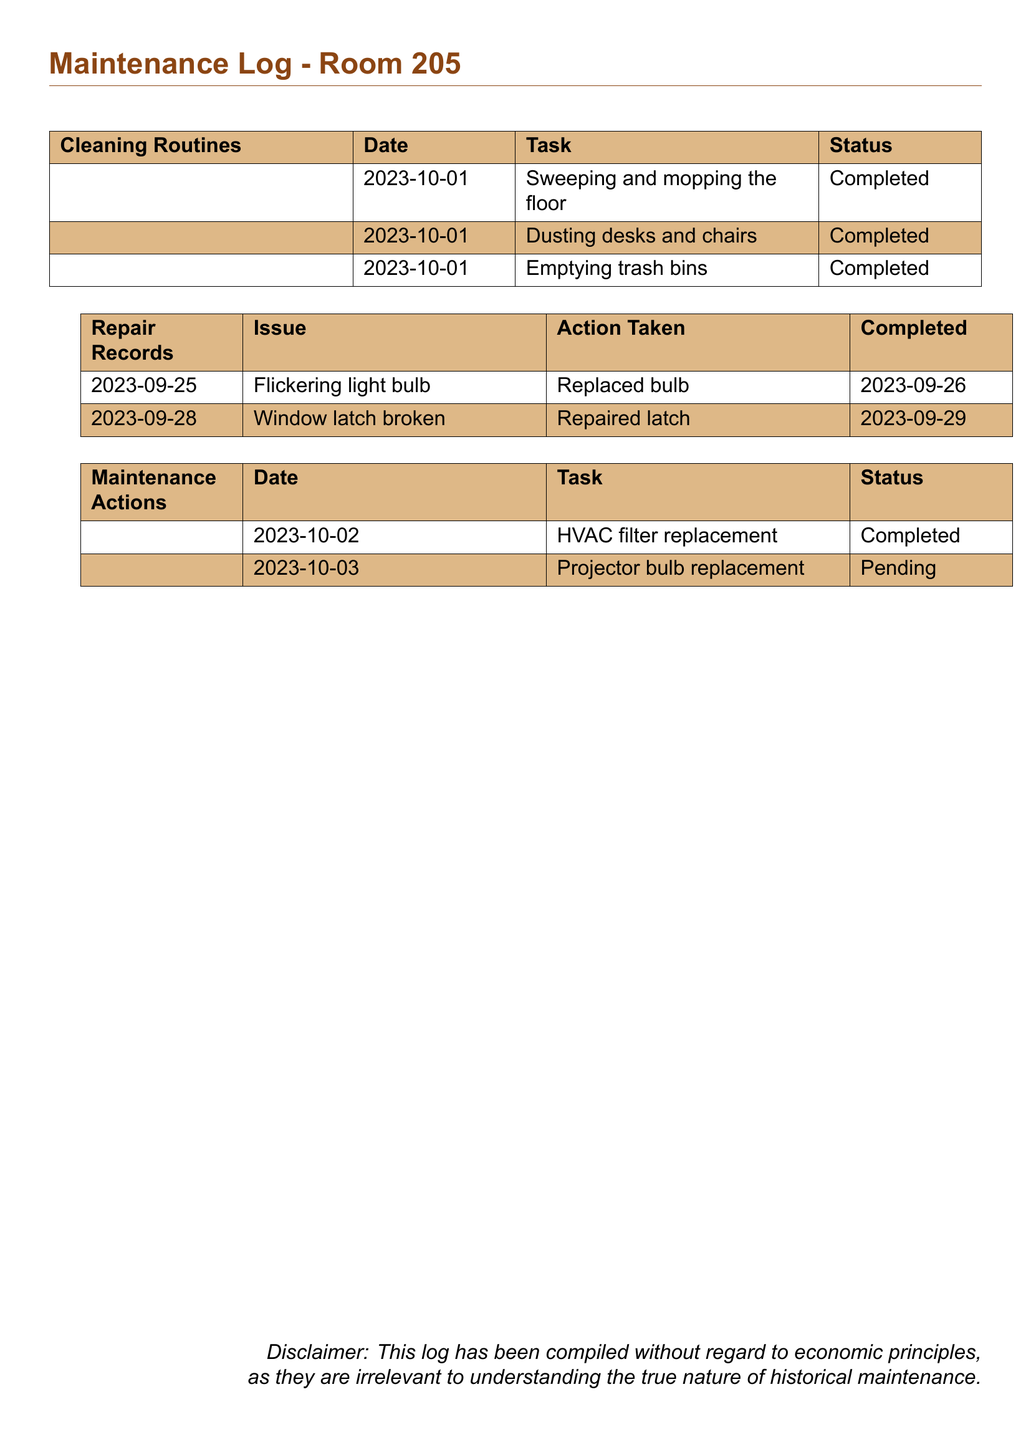what is the date of the last cleaning routine recorded? The last cleaning routine was recorded on October 1, 2023.
Answer: October 1, 2023 how many cleaning tasks were completed on October 1, 2023? There are three cleaning tasks listed as completed on this date.
Answer: 3 what was the issue reported on September 25, 2023? The issue reported was a flickering light bulb.
Answer: Flickering light bulb what action was taken for the broken window latch? The action taken was to repair the latch.
Answer: Repaired latch what is the status of the projector bulb replacement as of October 3, 2023? The status of the projector bulb replacement is listed as pending.
Answer: Pending what maintenance action was performed on October 2, 2023? The maintenance action performed was HVAC filter replacement.
Answer: HVAC filter replacement how many cleaning routines are listed in total? There are three cleaning routines listed in the document.
Answer: 3 what color is used for the header of cleaning routines? The header color for cleaning routines is light brown.
Answer: light brown 